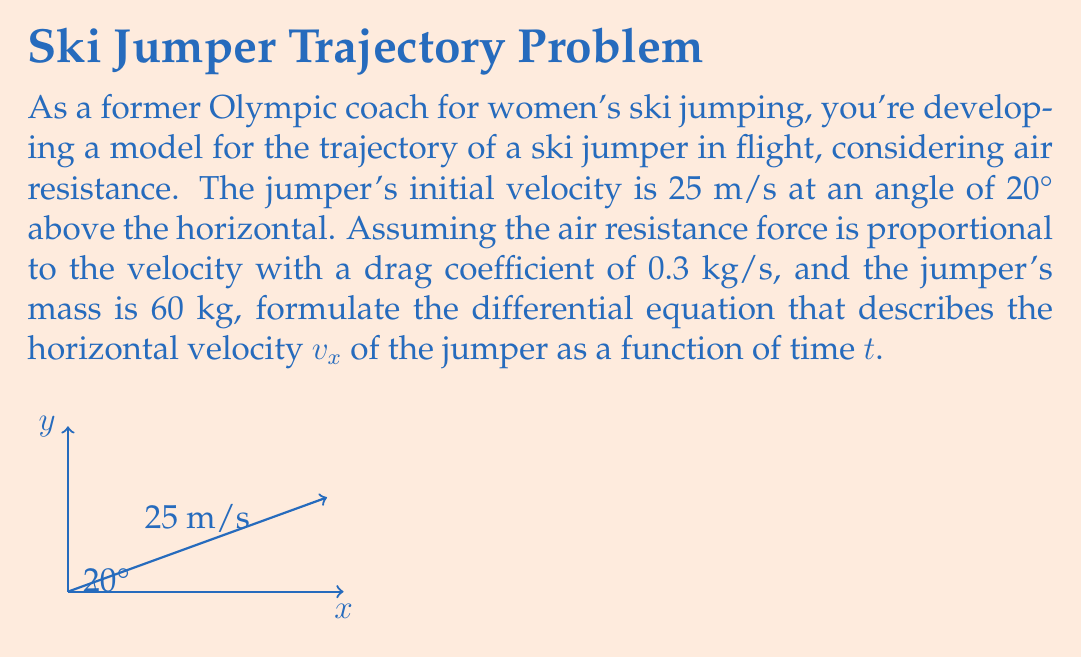Can you solve this math problem? Let's approach this step-by-step:

1) First, we need to consider the forces acting on the ski jumper in the horizontal direction:
   - Air resistance force (opposite to the direction of motion)
   - No other horizontal forces (assuming no wind)

2) The air resistance force is given by $F_d = -bv$, where $b$ is the drag coefficient and $v$ is the velocity. In this case, $b = 0.3$ kg/s.

3) For the horizontal component, we have:
   $F_x = -bv_x$

4) Using Newton's Second Law, $F = ma$, we can write:
   $-bv_x = m\frac{dv_x}{dt}$

5) Substituting the given values:
   $-0.3v_x = 60\frac{dv_x}{dt}$

6) Rearranging to standard form:
   $\frac{dv_x}{dt} + \frac{0.3}{60}v_x = 0$

7) Simplifying:
   $\frac{dv_x}{dt} + 0.005v_x = 0$

This is the differential equation that describes the horizontal velocity $v_x$ of the jumper as a function of time $t$, considering air resistance.

Note: The initial velocity's horizontal component would be $v_x(0) = 25\cos(20°)$ m/s, which could be used as an initial condition to solve this differential equation.
Answer: $$\frac{dv_x}{dt} + 0.005v_x = 0$$ 